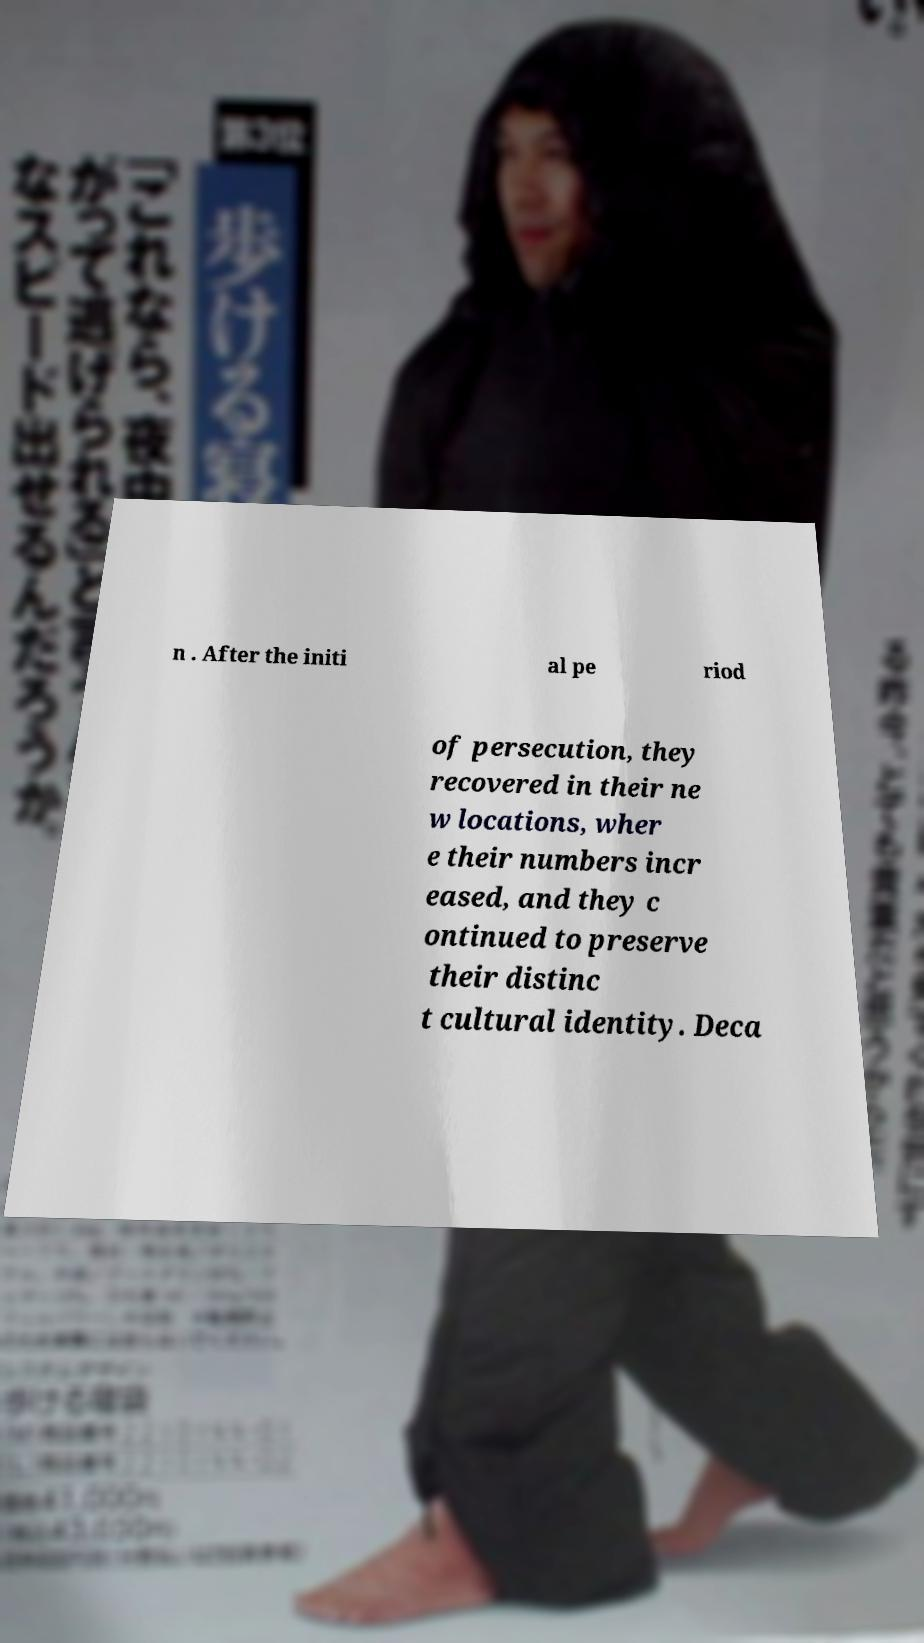There's text embedded in this image that I need extracted. Can you transcribe it verbatim? n . After the initi al pe riod of persecution, they recovered in their ne w locations, wher e their numbers incr eased, and they c ontinued to preserve their distinc t cultural identity. Deca 